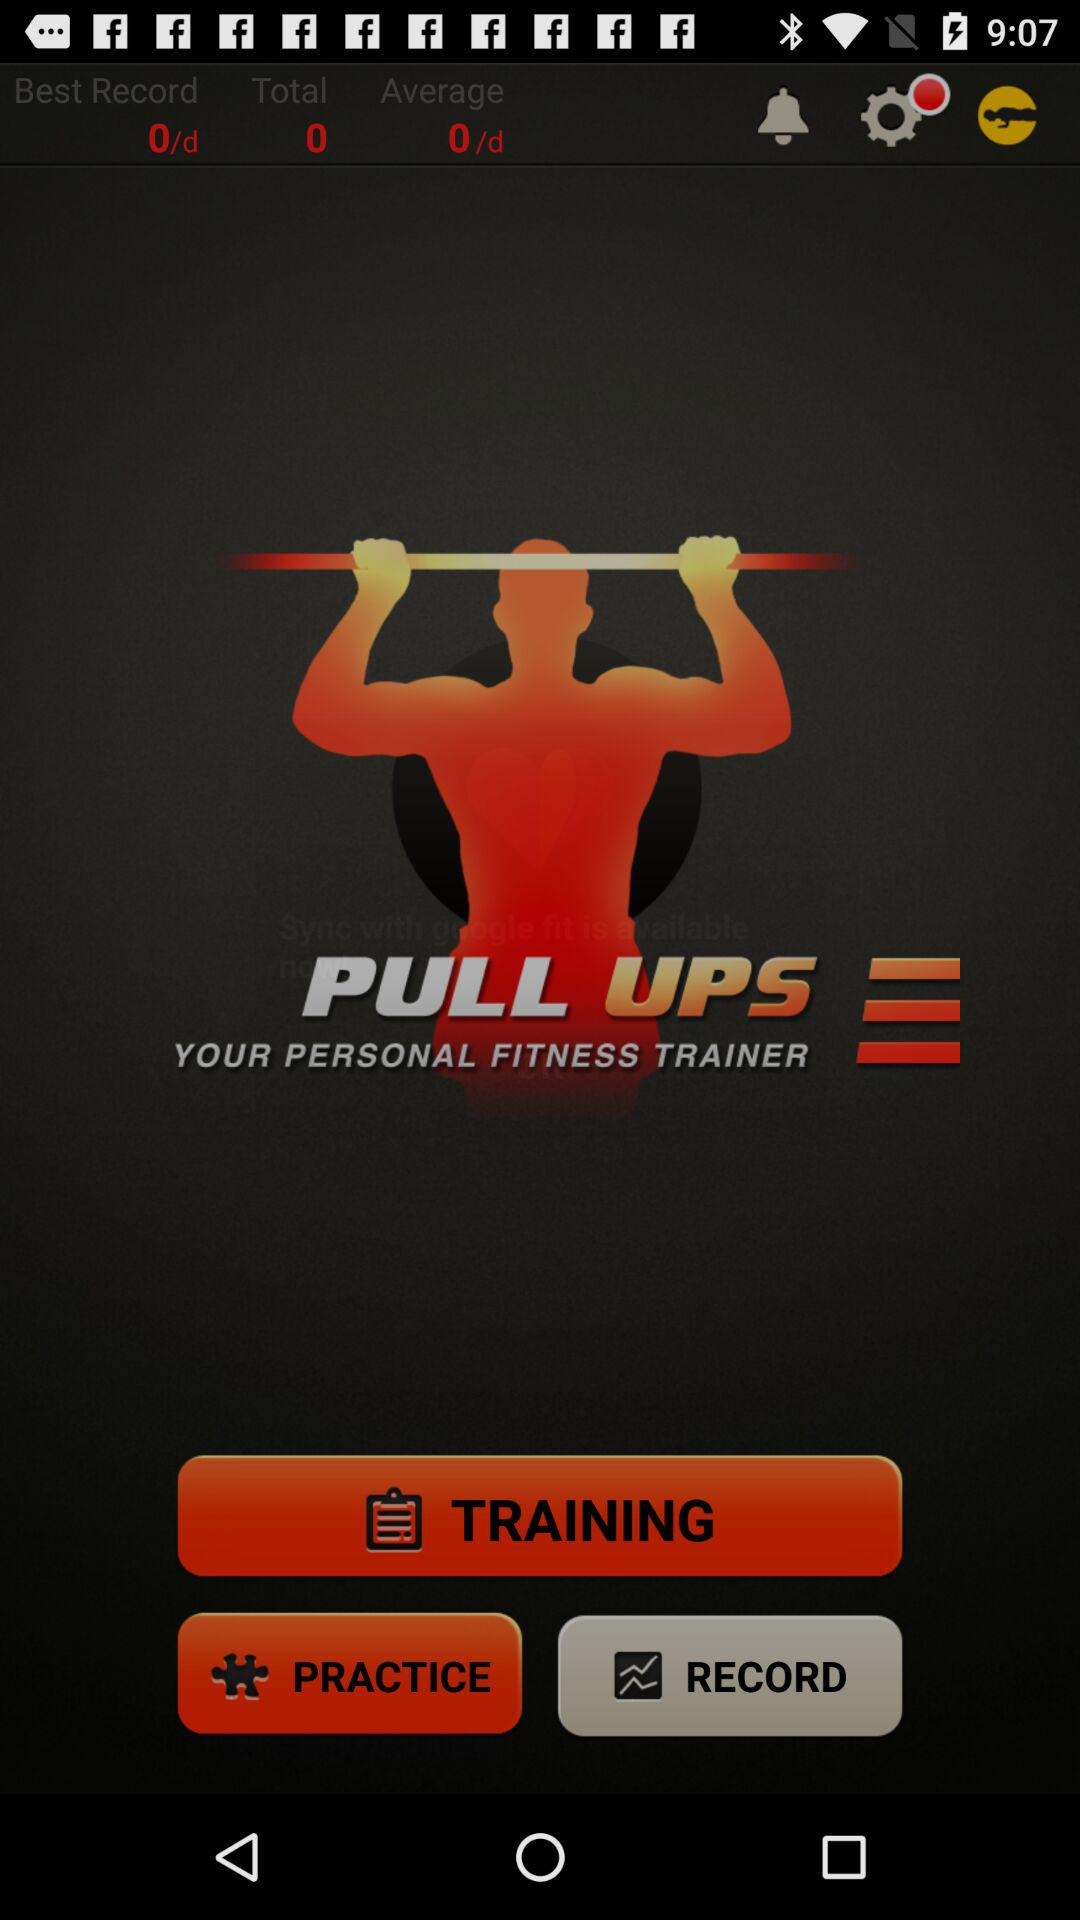What is the average? The average is 0 per day. 